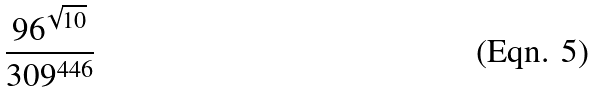<formula> <loc_0><loc_0><loc_500><loc_500>\frac { 9 6 ^ { \sqrt { 1 0 } } } { 3 0 9 ^ { 4 4 6 } }</formula> 